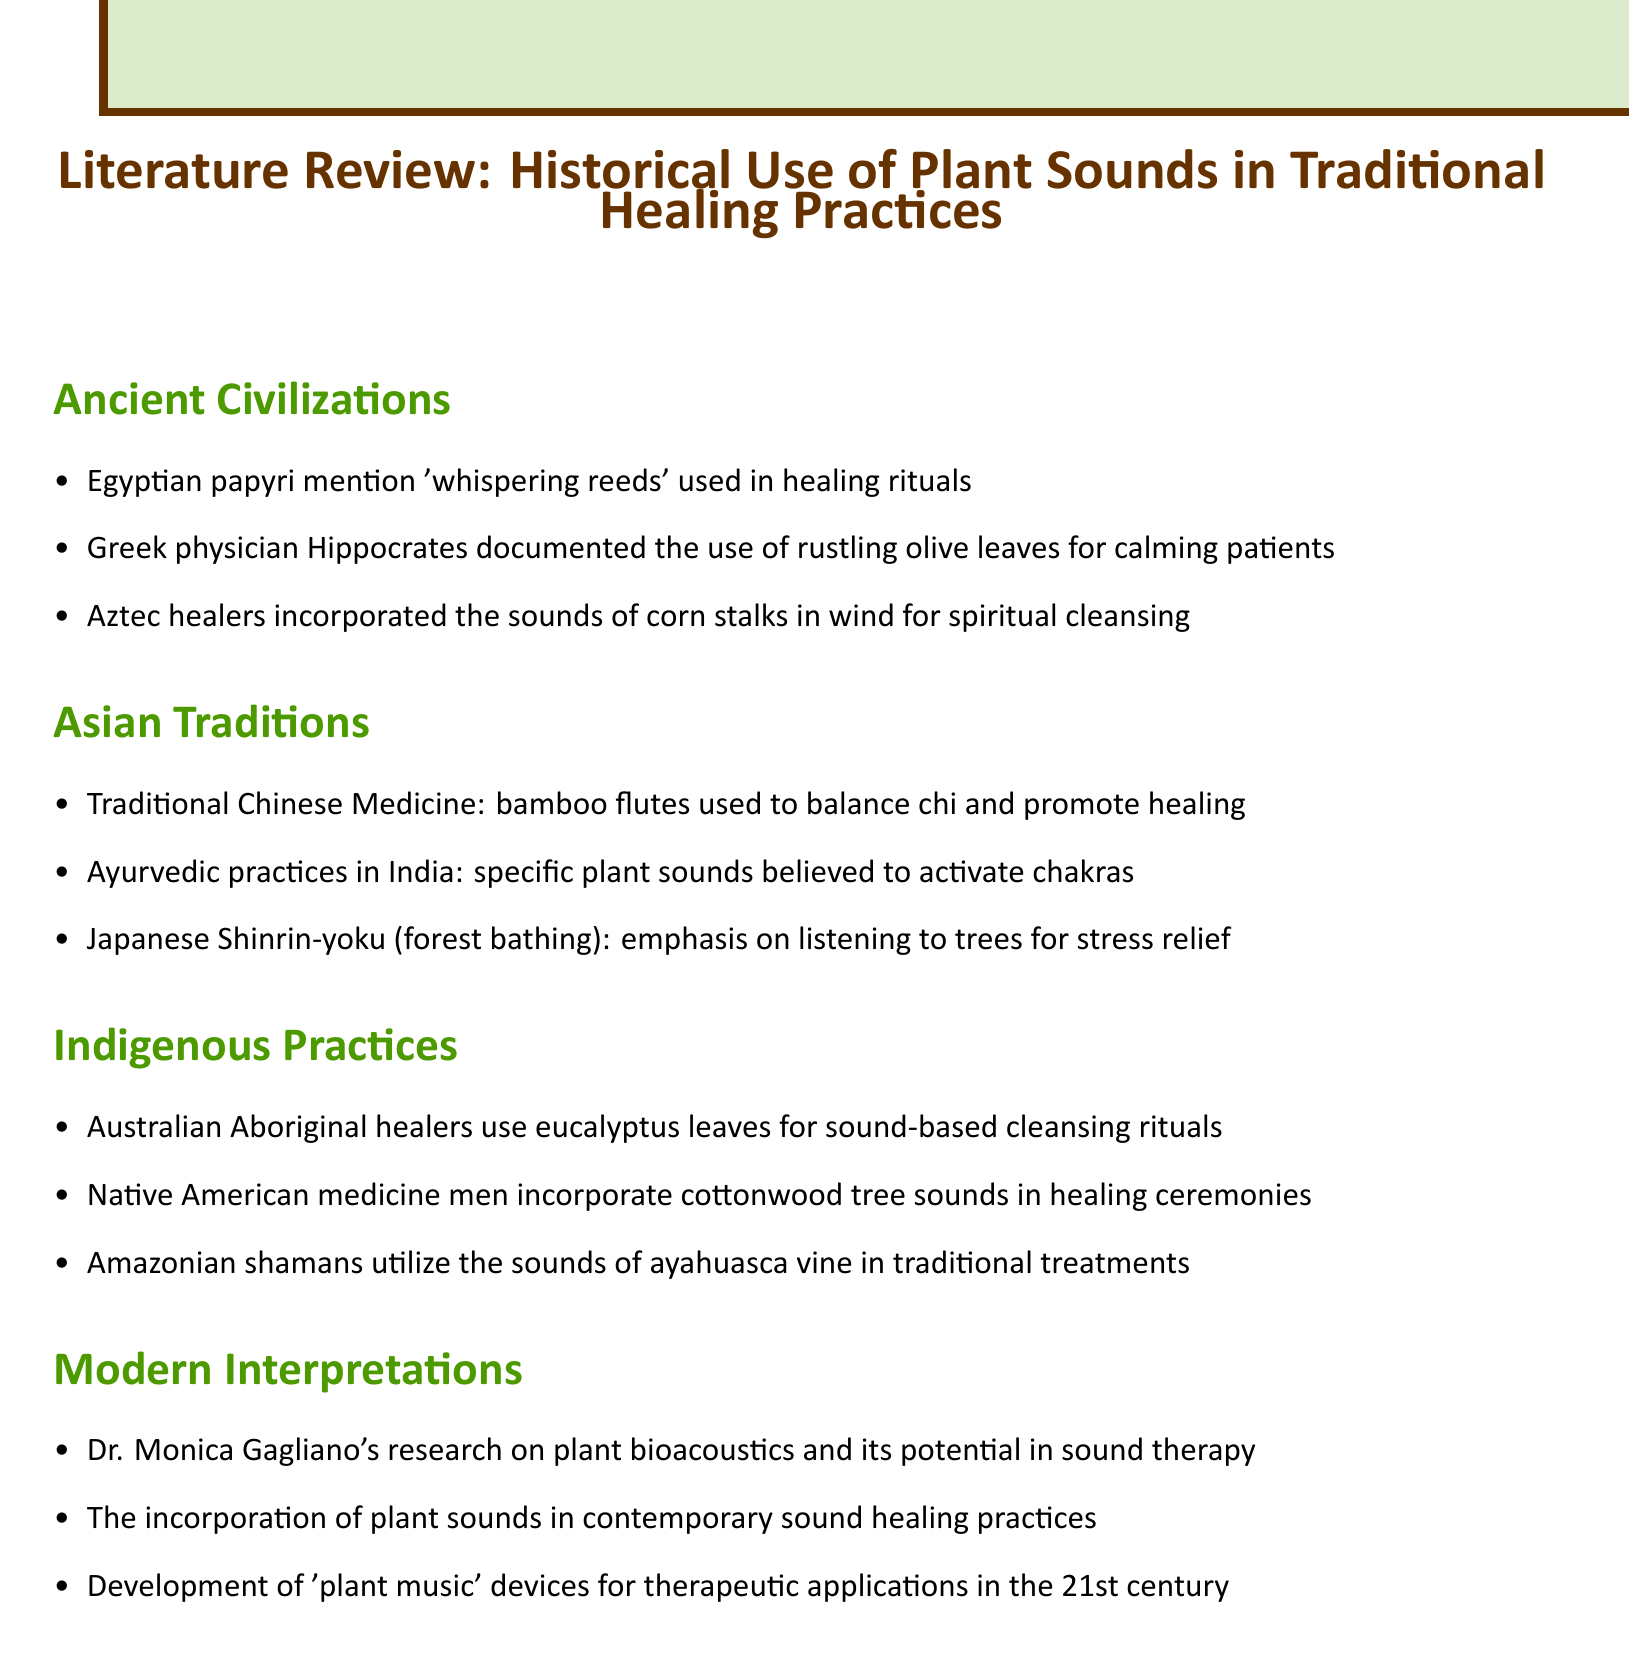What plant sounds were used in ancient Egyptian healing rituals? The document mentions the use of 'whispering reeds' in healing rituals according to Egyptian papyri.
Answer: 'whispering reeds' Who documented the calming effect of rustling olive leaves? The Greek physician Hippocrates is noted for documenting the use of rustling olive leaves for calming patients.
Answer: Hippocrates Which instrument is used in Traditional Chinese Medicine for healing? The document states that bamboo flutes are used to balance chi and promote healing in Traditional Chinese Medicine.
Answer: bamboo flutes What plant's sounds do Native American medicine men incorporate into their healing ceremonies? The sounds of cottonwood trees are incorporated into healing ceremonies by Native American medicine men.
Answer: cottonwood tree sounds Who conducted research on plant bioacoustics? Dr. Monica Gagliano's research on plant bioacoustics is mentioned in the modern interpretations section.
Answer: Dr. Monica Gagliano What is the practice called in Japan that emphasizes listening to trees? The practice is known as Shinrin-yoku, or forest bathing, which emphasizes listening to trees for stress relief.
Answer: Shinrin-yoku Which traditional healing practice utilizes the sounds of ayahuasca vine? Amazonian shamans utilize the sounds of ayahuasca vine in their traditional treatments.
Answer: ayahuasca vine How have plant sounds been incorporated into contemporary practices? The document notes that plant sounds have been incorporated into contemporary sound healing practices.
Answer: sound healing practices What ritual do Australian Aboriginal healers perform with eucalyptus leaves? Australian Aboriginal healers use eucalyptus leaves for sound-based cleansing rituals.
Answer: sound-based cleansing rituals 